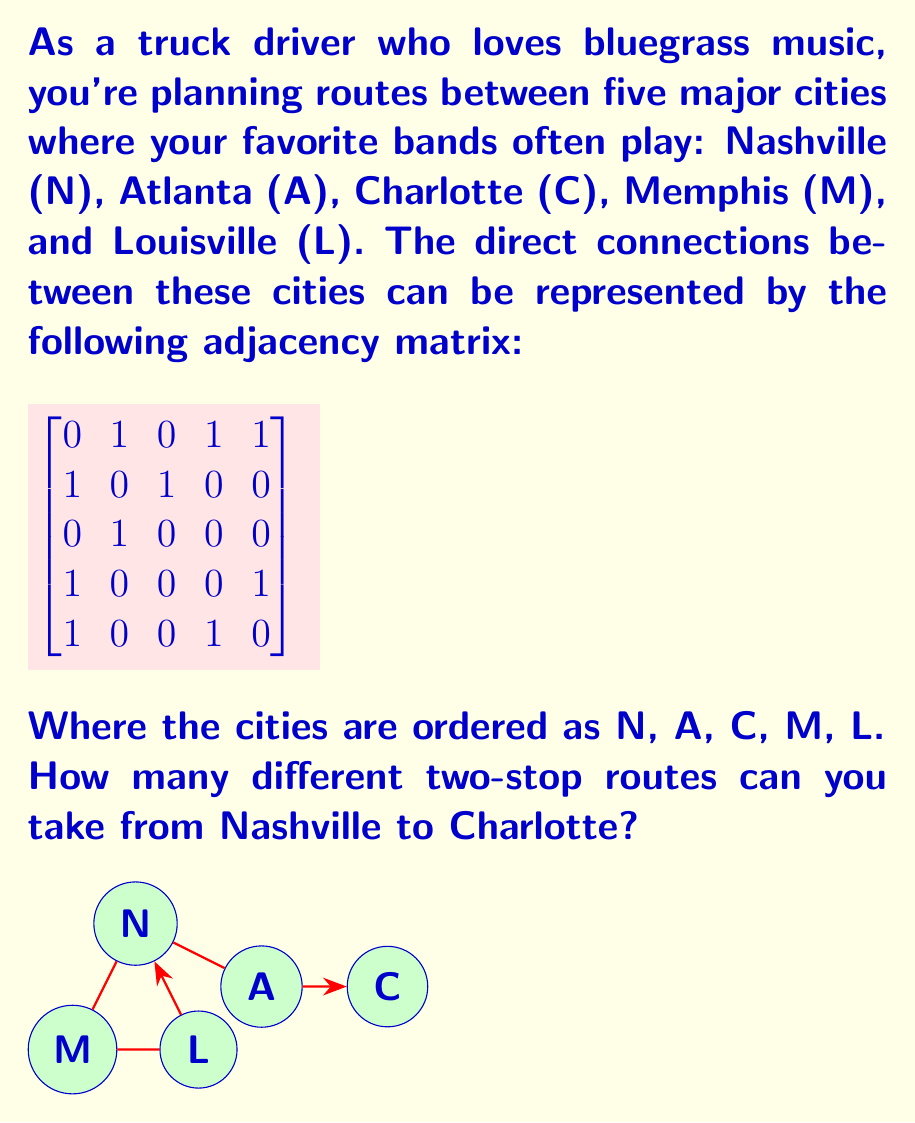What is the answer to this math problem? Let's approach this step-by-step:

1) A two-stop route from Nashville to Charlotte means we need to go through two other cities before reaching Charlotte. In matrix terms, this is equivalent to finding the number of paths of length 3 from Nashville to Charlotte.

2) To find paths of length 3, we need to cube the adjacency matrix. Let's call our original matrix A. We're looking for the element in the 1st row (Nashville) and 3rd column (Charlotte) of A³.

3) Let's calculate A²:

   $$A^2 = \begin{bmatrix}
   0 & 1 & 0 & 1 & 1 \\
   1 & 0 & 1 & 0 & 0 \\
   0 & 1 & 0 & 0 & 0 \\
   1 & 0 & 0 & 0 & 1 \\
   1 & 0 & 0 & 1 & 0
   \end{bmatrix} \times \begin{bmatrix}
   0 & 1 & 0 & 1 & 1 \\
   1 & 0 & 1 & 0 & 0 \\
   0 & 1 & 0 & 0 & 0 \\
   1 & 0 & 0 & 0 & 1 \\
   1 & 0 & 0 & 1 & 0
   \end{bmatrix} = \begin{bmatrix}
   3 & 0 & 1 & 1 & 1 \\
   0 & 2 & 0 & 1 & 1 \\
   1 & 0 & 1 & 0 & 0 \\
   1 & 1 & 0 & 2 & 1 \\
   1 & 1 & 0 & 1 & 2
   \end{bmatrix}$$

4) Now let's calculate A³:

   $$A^3 = A \times A^2 = \begin{bmatrix}
   0 & 1 & 0 & 1 & 1 \\
   1 & 0 & 1 & 0 & 0 \\
   0 & 1 & 0 & 0 & 0 \\
   1 & 0 & 0 & 0 & 1 \\
   1 & 0 & 0 & 1 & 0
   \end{bmatrix} \times \begin{bmatrix}
   3 & 0 & 1 & 1 & 1 \\
   0 & 2 & 0 & 1 & 1 \\
   1 & 0 & 1 & 0 & 0 \\
   1 & 1 & 0 & 2 & 1 \\
   1 & 1 & 0 & 1 & 2
   \end{bmatrix} = \begin{bmatrix}
   2 & 4 & 0 & 4 & 4 \\
   4 & 0 & 2 & 1 & 1 \\
   0 & 2 & 0 & 1 & 1 \\
   4 & 1 & 1 & 2 & 3 \\
   4 & 1 & 1 & 3 & 2
   \end{bmatrix}$$

5) The element in the 1st row and 3rd column of A³ is 0.

Therefore, there are 0 different two-stop routes from Nashville to Charlotte.
Answer: 0 